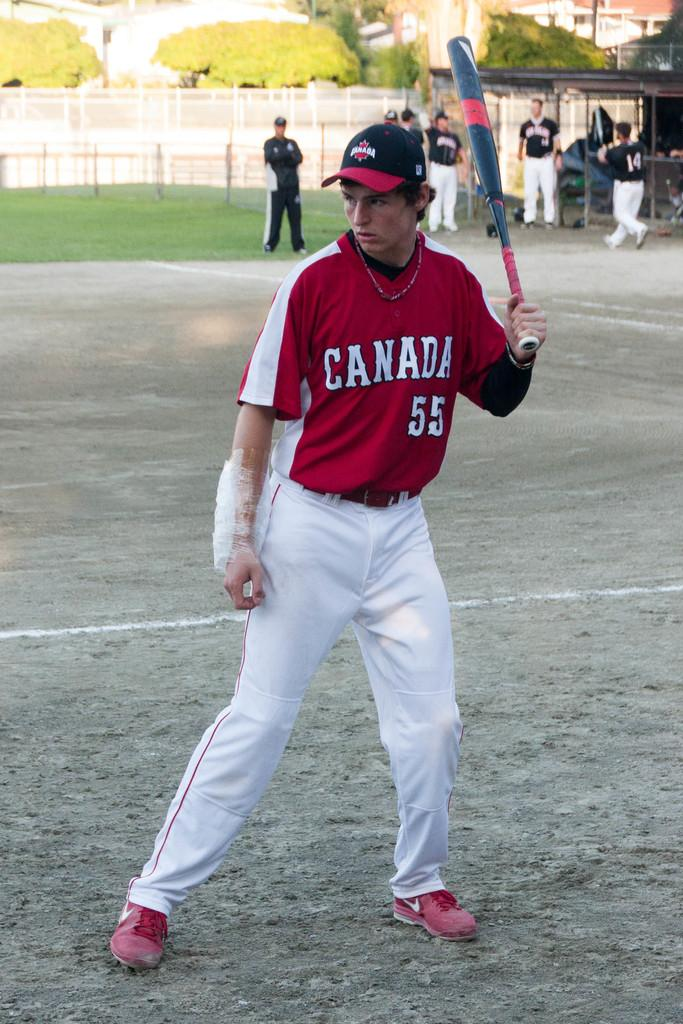<image>
Provide a brief description of the given image. a boy with a Canada baseball jersey on 